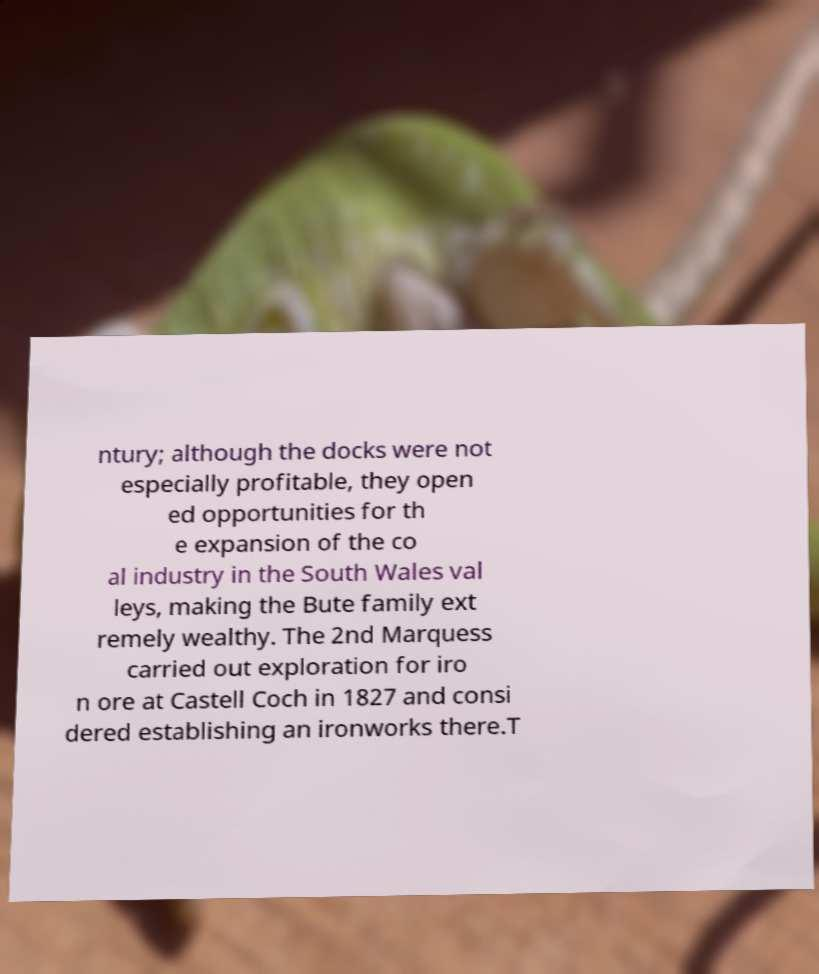Please read and relay the text visible in this image. What does it say? ntury; although the docks were not especially profitable, they open ed opportunities for th e expansion of the co al industry in the South Wales val leys, making the Bute family ext remely wealthy. The 2nd Marquess carried out exploration for iro n ore at Castell Coch in 1827 and consi dered establishing an ironworks there.T 